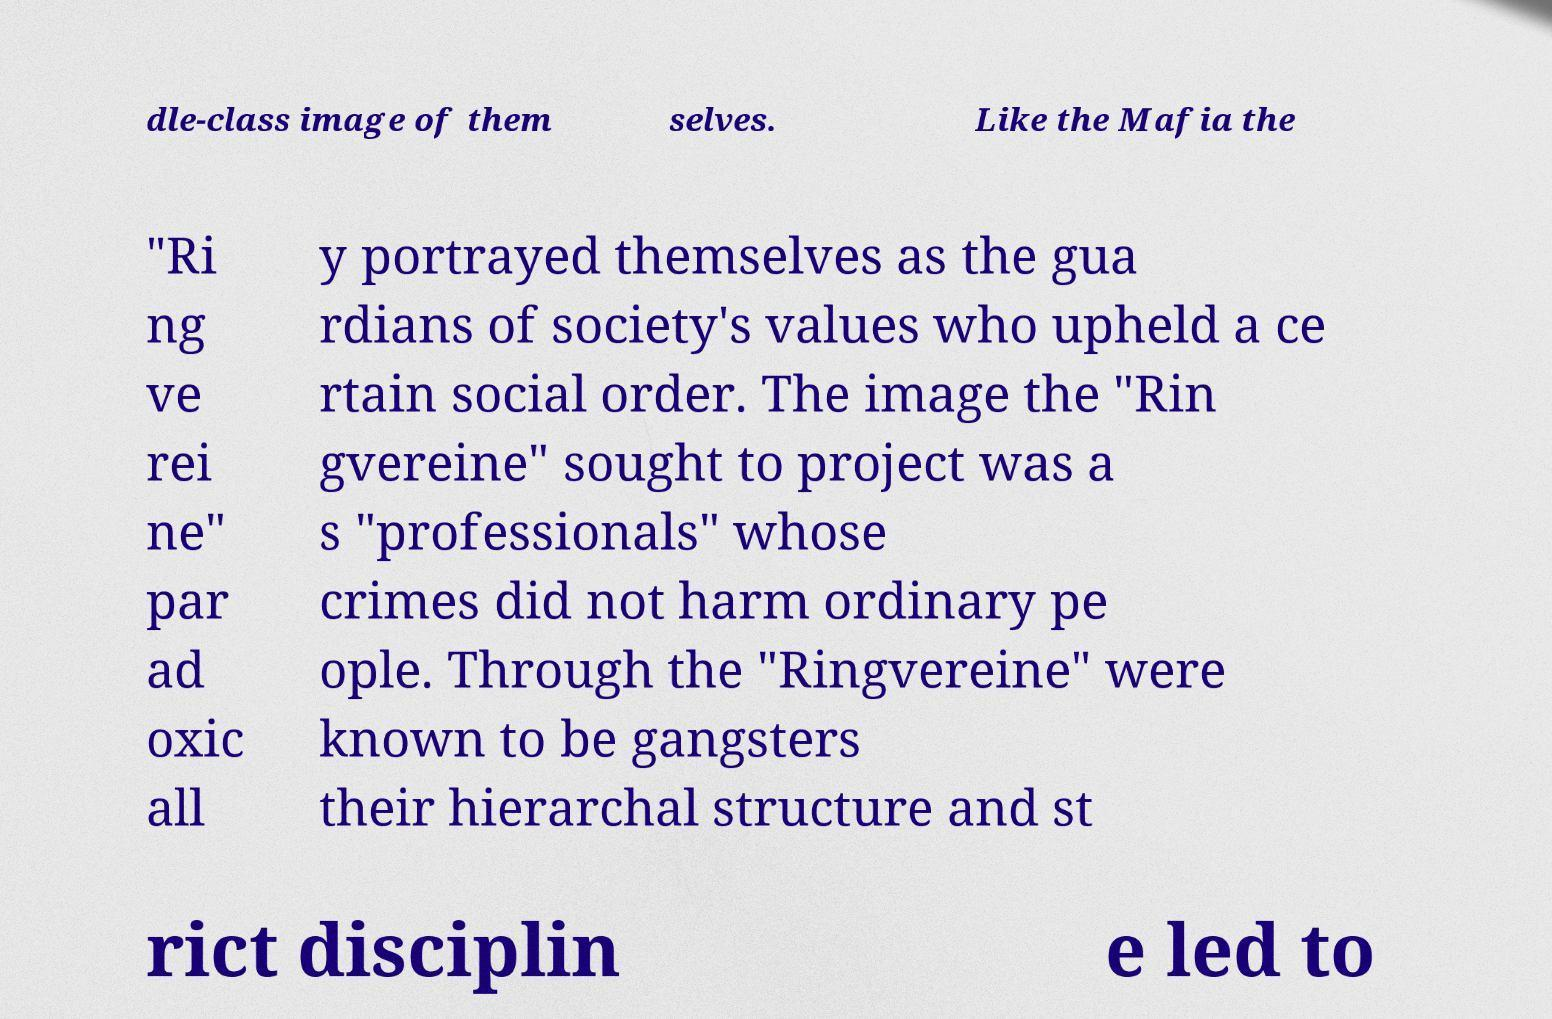Please read and relay the text visible in this image. What does it say? dle-class image of them selves. Like the Mafia the "Ri ng ve rei ne" par ad oxic all y portrayed themselves as the gua rdians of society's values who upheld a ce rtain social order. The image the "Rin gvereine" sought to project was a s "professionals" whose crimes did not harm ordinary pe ople. Through the "Ringvereine" were known to be gangsters their hierarchal structure and st rict disciplin e led to 